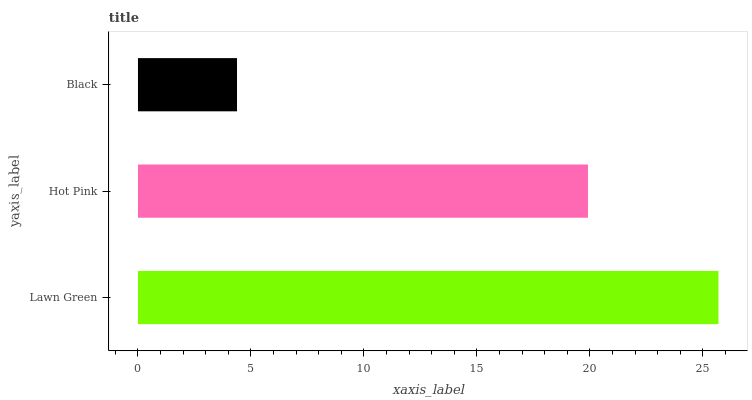Is Black the minimum?
Answer yes or no. Yes. Is Lawn Green the maximum?
Answer yes or no. Yes. Is Hot Pink the minimum?
Answer yes or no. No. Is Hot Pink the maximum?
Answer yes or no. No. Is Lawn Green greater than Hot Pink?
Answer yes or no. Yes. Is Hot Pink less than Lawn Green?
Answer yes or no. Yes. Is Hot Pink greater than Lawn Green?
Answer yes or no. No. Is Lawn Green less than Hot Pink?
Answer yes or no. No. Is Hot Pink the high median?
Answer yes or no. Yes. Is Hot Pink the low median?
Answer yes or no. Yes. Is Black the high median?
Answer yes or no. No. Is Black the low median?
Answer yes or no. No. 